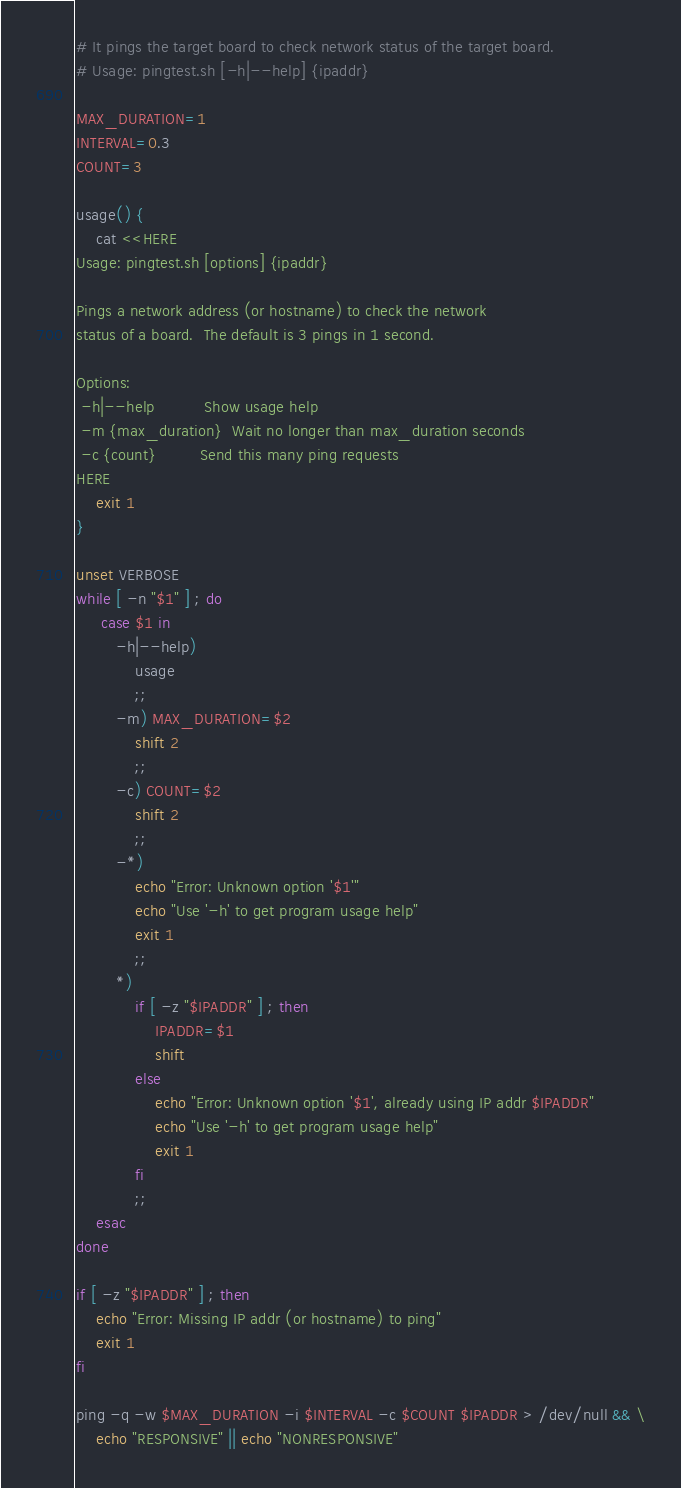Convert code to text. <code><loc_0><loc_0><loc_500><loc_500><_Bash_># It pings the target board to check network status of the target board.
# Usage: pingtest.sh [-h|--help] {ipaddr}

MAX_DURATION=1
INTERVAL=0.3
COUNT=3

usage() {
    cat <<HERE
Usage: pingtest.sh [options] {ipaddr}

Pings a network address (or hostname) to check the network
status of a board.  The default is 3 pings in 1 second.

Options:
 -h|--help          Show usage help
 -m {max_duration}  Wait no longer than max_duration seconds
 -c {count}         Send this many ping requests
HERE
    exit 1
}

unset VERBOSE
while [ -n "$1" ] ; do
     case $1 in
        -h|--help)
            usage
            ;;
        -m) MAX_DURATION=$2
            shift 2
            ;;
        -c) COUNT=$2
            shift 2
            ;;
        -*)
            echo "Error: Unknown option '$1'"
            echo "Use '-h' to get program usage help"
            exit 1
            ;;
        *)
            if [ -z "$IPADDR" ] ; then
                IPADDR=$1
                shift
            else
                echo "Error: Unknown option '$1', already using IP addr $IPADDR"
                echo "Use '-h' to get program usage help"
                exit 1
            fi
            ;;
    esac
done

if [ -z "$IPADDR" ] ; then
    echo "Error: Missing IP addr (or hostname) to ping"
    exit 1
fi

ping -q -w $MAX_DURATION -i $INTERVAL -c $COUNT $IPADDR > /dev/null && \
    echo "RESPONSIVE" || echo "NONRESPONSIVE"
</code> 